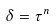Convert formula to latex. <formula><loc_0><loc_0><loc_500><loc_500>\delta = \tau ^ { n }</formula> 